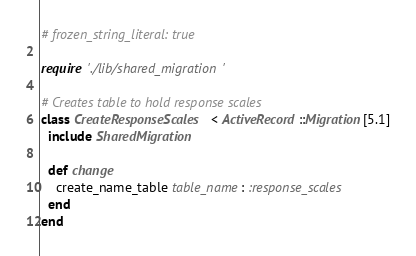<code> <loc_0><loc_0><loc_500><loc_500><_Ruby_># frozen_string_literal: true

require './lib/shared_migration'

# Creates table to hold response scales
class CreateResponseScales < ActiveRecord::Migration[5.1]
  include SharedMigration

  def change
    create_name_table table_name: :response_scales
  end
end
</code> 